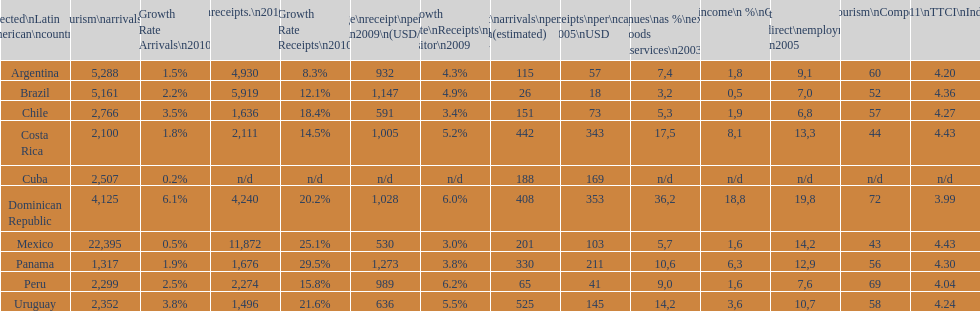What was the number of international tourists arriving in mexico in 2010 (in thousands)? 22,395. 